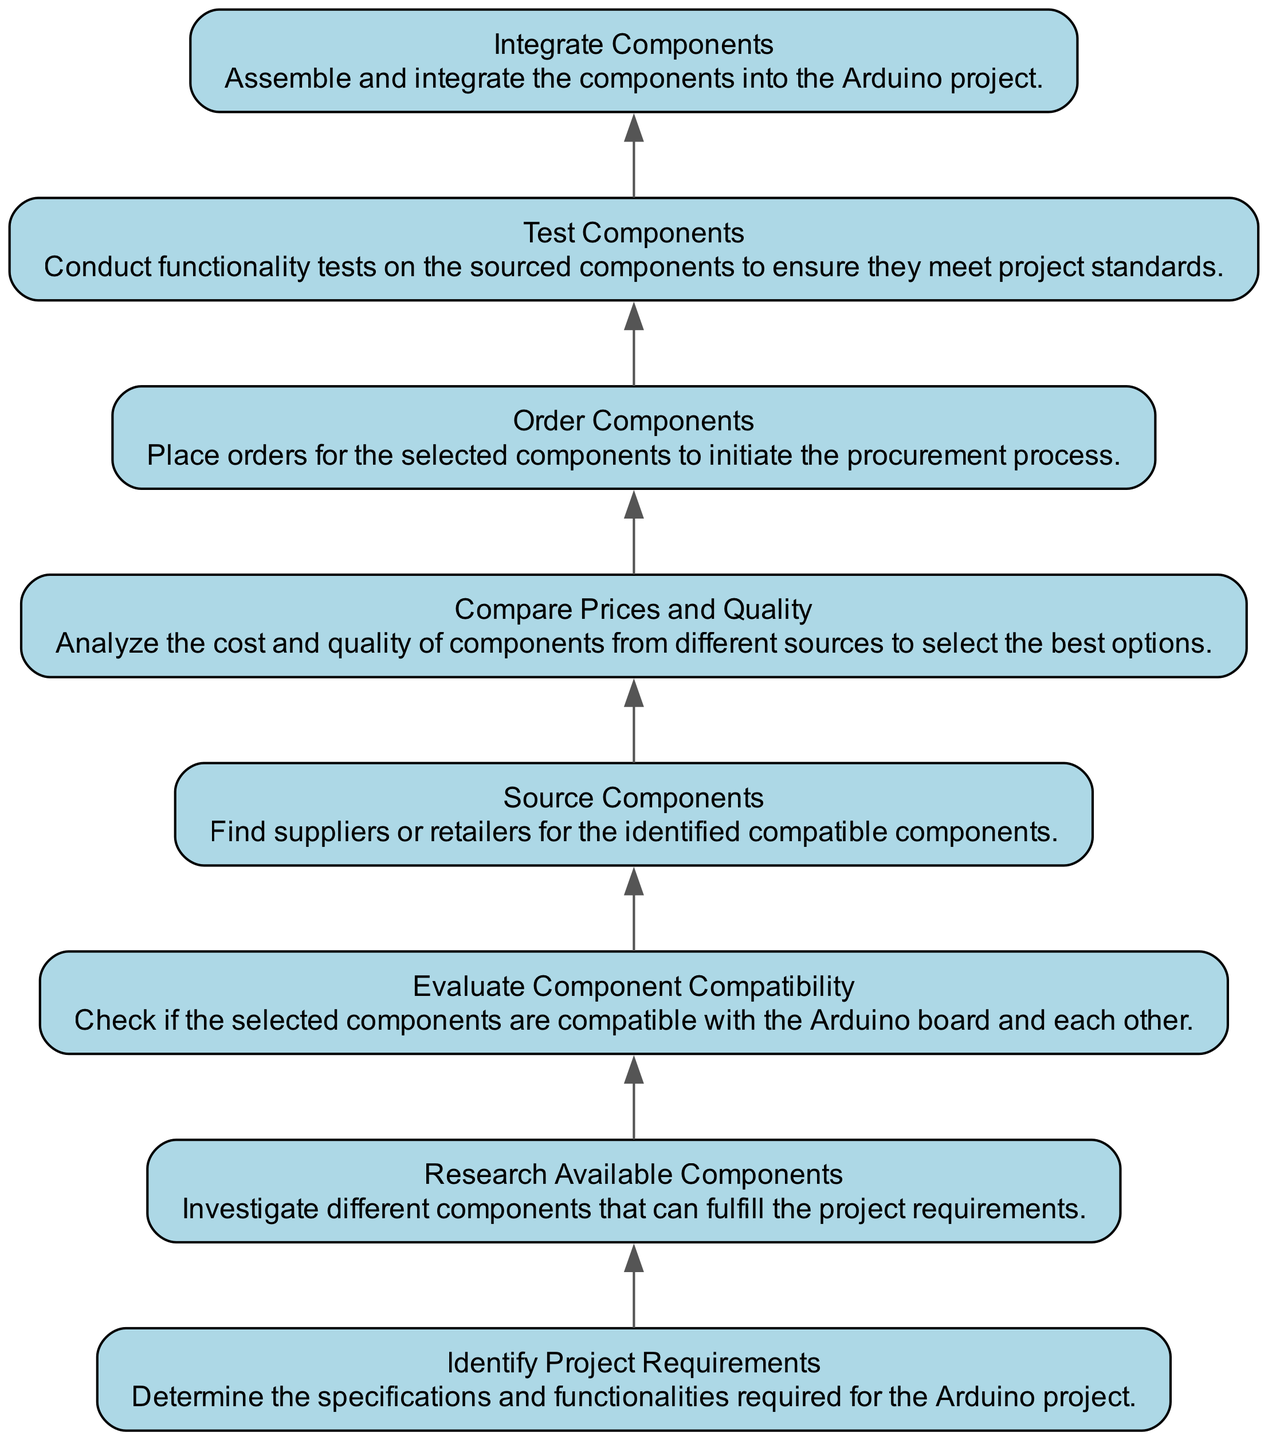What is the first step in the flow chart? The first step is identified by the node labeled "Identify Project Requirements," which denotes the initial action required for the project.
Answer: Identify Project Requirements What comes after researching available components? After "Research Available Components," the next node in the flow chart is "Evaluate Component Compatibility," indicating that compatibility assessment follows research.
Answer: Evaluate Component Compatibility How many nodes are present in the diagram? Counting all the unique stages in the flow chart, there are eight distinct nodes that outline the process of component sourcing and selection.
Answer: 8 Which step involves placing orders for components? The step that directly involves placing orders is labeled "Order Components," which is positioned after comparing prices and quality.
Answer: Order Components What are the last two steps in the flow? The last two steps in the flow of the diagram are "Test Components" followed by "Integrate Components," reflecting the final actions in the project process.
Answer: Test Components, Integrate Components What is the relationship between “Source Components” and “Compare Prices and Quality”? "Source Components" leads directly to "Compare Prices and Quality," indicating that once components are sourced, the next action is to analyze their prices and quality.
Answer: Source Components leads to Compare Prices and Quality Which node checks for compatibility? The node that checks for compatibility is "Evaluate Component Compatibility," which is crucial for ensuring that selected components can work together.
Answer: Evaluate Component Compatibility If all steps are followed, what is the final action? The final action in the flow chart, after all prior steps have been completed, is "Integrate Components," where the components are brought together into the project.
Answer: Integrate Components What is the main purpose of the "Test Components" step? The main purpose of the "Test Components" step is to conduct functionality tests, ensuring that the sourced components meet the established project standards.
Answer: Conduct functionality tests 